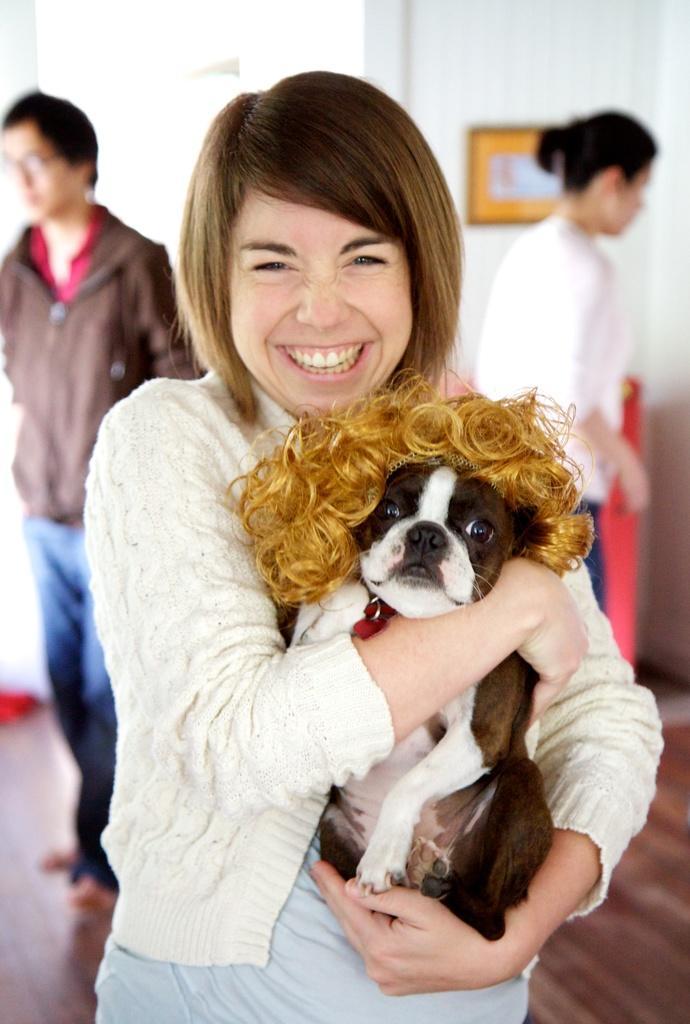Describe this image in one or two sentences. a person is holding a dog. behind her there are 2 more people standing. 